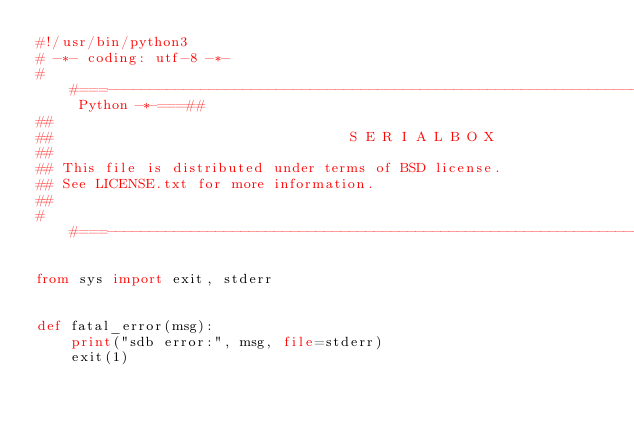<code> <loc_0><loc_0><loc_500><loc_500><_Python_>#!/usr/bin/python3
# -*- coding: utf-8 -*-
##===-----------------------------------------------------------------------------*- Python -*-===##
##
##                                   S E R I A L B O X
##
## This file is distributed under terms of BSD license. 
## See LICENSE.txt for more information.
##
##===------------------------------------------------------------------------------------------===##

from sys import exit, stderr


def fatal_error(msg):
    print("sdb error:", msg, file=stderr)
    exit(1)
</code> 